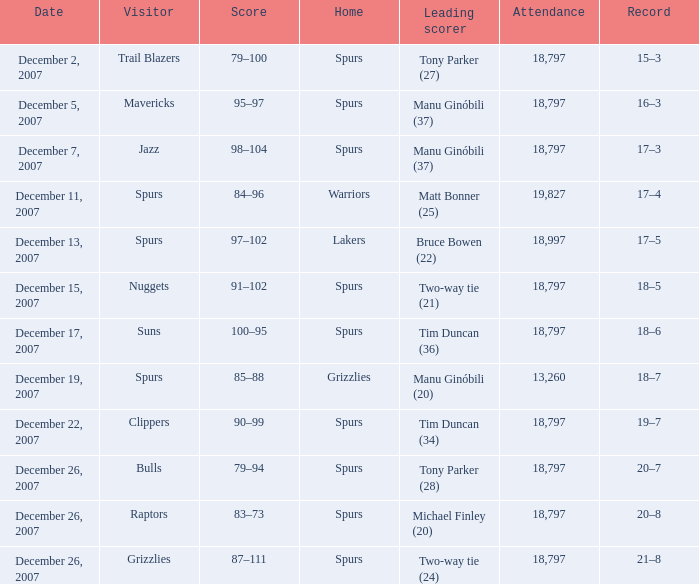What was the game's outcome on december 5, 2007? 16–3. 